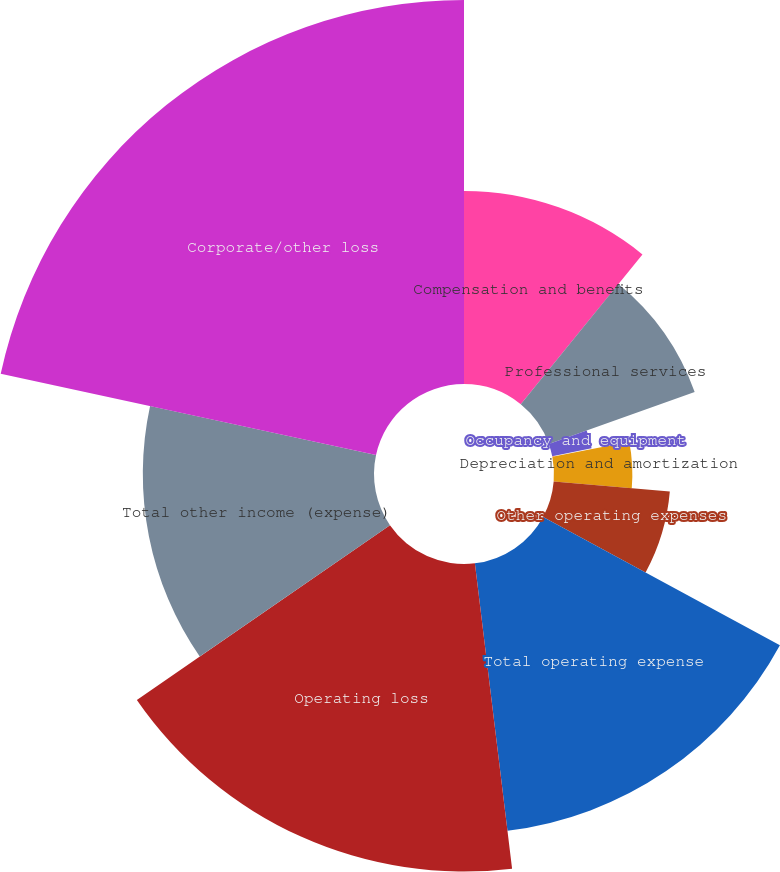Convert chart to OTSL. <chart><loc_0><loc_0><loc_500><loc_500><pie_chart><fcel>Compensation and benefits<fcel>Professional services<fcel>Occupancy and equipment<fcel>Communications<fcel>Depreciation and amortization<fcel>Other operating expenses<fcel>Total operating expense<fcel>Operating loss<fcel>Total other income (expense)<fcel>Corporate/other loss<nl><fcel>10.86%<fcel>8.71%<fcel>2.26%<fcel>0.11%<fcel>4.41%<fcel>6.56%<fcel>15.16%<fcel>17.31%<fcel>13.01%<fcel>21.61%<nl></chart> 